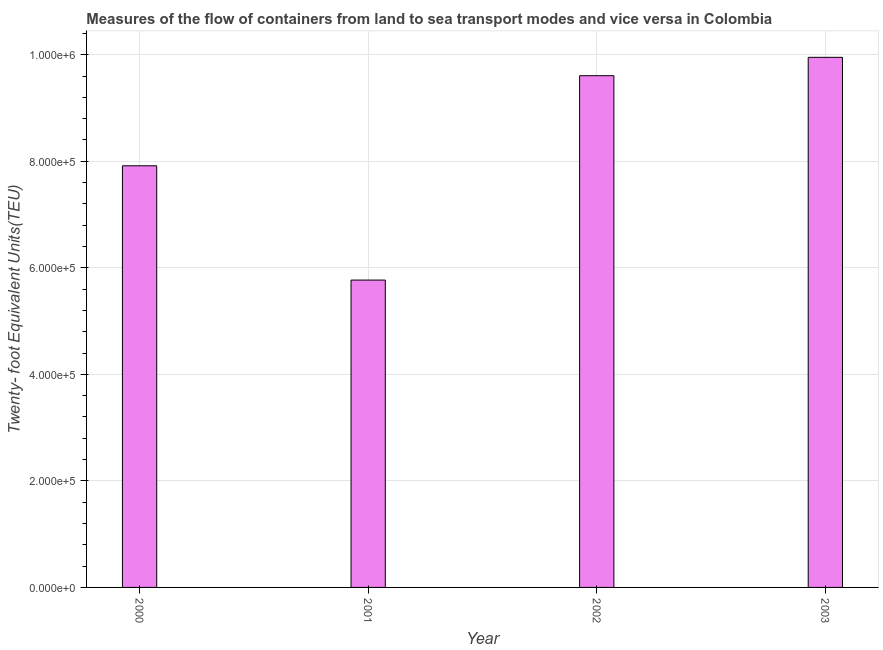Does the graph contain any zero values?
Your answer should be compact. No. Does the graph contain grids?
Ensure brevity in your answer.  Yes. What is the title of the graph?
Provide a succinct answer. Measures of the flow of containers from land to sea transport modes and vice versa in Colombia. What is the label or title of the Y-axis?
Your response must be concise. Twenty- foot Equivalent Units(TEU). What is the container port traffic in 2001?
Ensure brevity in your answer.  5.77e+05. Across all years, what is the maximum container port traffic?
Offer a very short reply. 9.95e+05. Across all years, what is the minimum container port traffic?
Ensure brevity in your answer.  5.77e+05. In which year was the container port traffic maximum?
Offer a very short reply. 2003. What is the sum of the container port traffic?
Give a very brief answer. 3.32e+06. What is the difference between the container port traffic in 2000 and 2003?
Offer a terse response. -2.04e+05. What is the average container port traffic per year?
Keep it short and to the point. 8.31e+05. What is the median container port traffic?
Offer a very short reply. 8.76e+05. Do a majority of the years between 2003 and 2000 (inclusive) have container port traffic greater than 520000 TEU?
Make the answer very short. Yes. What is the ratio of the container port traffic in 2000 to that in 2002?
Make the answer very short. 0.82. Is the container port traffic in 2000 less than that in 2003?
Provide a short and direct response. Yes. Is the difference between the container port traffic in 2000 and 2003 greater than the difference between any two years?
Make the answer very short. No. What is the difference between the highest and the second highest container port traffic?
Offer a very short reply. 3.45e+04. What is the difference between the highest and the lowest container port traffic?
Make the answer very short. 4.18e+05. In how many years, is the container port traffic greater than the average container port traffic taken over all years?
Your answer should be compact. 2. Are all the bars in the graph horizontal?
Give a very brief answer. No. What is the Twenty- foot Equivalent Units(TEU) of 2000?
Make the answer very short. 7.92e+05. What is the Twenty- foot Equivalent Units(TEU) in 2001?
Provide a short and direct response. 5.77e+05. What is the Twenty- foot Equivalent Units(TEU) in 2002?
Give a very brief answer. 9.61e+05. What is the Twenty- foot Equivalent Units(TEU) in 2003?
Give a very brief answer. 9.95e+05. What is the difference between the Twenty- foot Equivalent Units(TEU) in 2000 and 2001?
Give a very brief answer. 2.15e+05. What is the difference between the Twenty- foot Equivalent Units(TEU) in 2000 and 2002?
Give a very brief answer. -1.69e+05. What is the difference between the Twenty- foot Equivalent Units(TEU) in 2000 and 2003?
Your answer should be compact. -2.04e+05. What is the difference between the Twenty- foot Equivalent Units(TEU) in 2001 and 2002?
Your answer should be compact. -3.84e+05. What is the difference between the Twenty- foot Equivalent Units(TEU) in 2001 and 2003?
Your answer should be very brief. -4.18e+05. What is the difference between the Twenty- foot Equivalent Units(TEU) in 2002 and 2003?
Your response must be concise. -3.45e+04. What is the ratio of the Twenty- foot Equivalent Units(TEU) in 2000 to that in 2001?
Offer a terse response. 1.37. What is the ratio of the Twenty- foot Equivalent Units(TEU) in 2000 to that in 2002?
Provide a short and direct response. 0.82. What is the ratio of the Twenty- foot Equivalent Units(TEU) in 2000 to that in 2003?
Your answer should be compact. 0.8. What is the ratio of the Twenty- foot Equivalent Units(TEU) in 2001 to that in 2002?
Make the answer very short. 0.6. What is the ratio of the Twenty- foot Equivalent Units(TEU) in 2001 to that in 2003?
Offer a very short reply. 0.58. What is the ratio of the Twenty- foot Equivalent Units(TEU) in 2002 to that in 2003?
Provide a succinct answer. 0.96. 